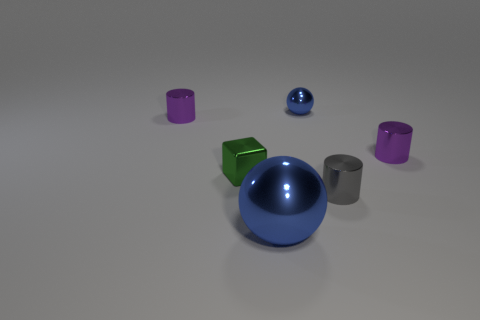Is the color of the large object the same as the tiny metal sphere behind the metallic block?
Give a very brief answer. Yes. There is a thing that is the same color as the big ball; what is its material?
Offer a very short reply. Metal. Does the metallic sphere that is right of the big shiny thing have the same color as the large thing?
Provide a short and direct response. Yes. There is a metal sphere behind the metallic cylinder on the left side of the large metal object; what size is it?
Provide a short and direct response. Small. What number of other blocks are the same size as the cube?
Make the answer very short. 0. Is the color of the shiny ball right of the large object the same as the big metal object that is right of the small green metallic object?
Offer a terse response. Yes. There is a big blue object; are there any small objects right of it?
Your answer should be very brief. Yes. What is the color of the tiny cylinder that is both right of the green shiny thing and behind the gray metallic thing?
Your response must be concise. Purple. Are there any small metallic objects of the same color as the large thing?
Provide a short and direct response. Yes. Do the purple cylinder that is on the right side of the tiny green shiny block and the large ball in front of the tiny gray thing have the same material?
Make the answer very short. Yes. 